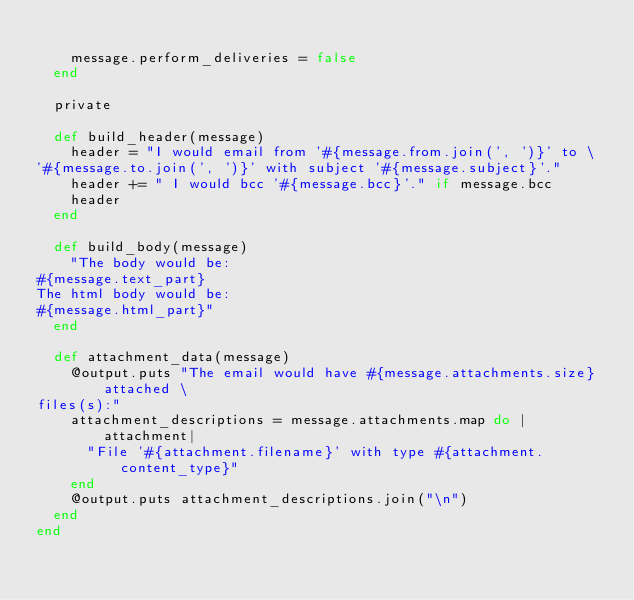<code> <loc_0><loc_0><loc_500><loc_500><_Ruby_>
    message.perform_deliveries = false
  end

  private

  def build_header(message)
    header = "I would email from '#{message.from.join(', ')}' to \
'#{message.to.join(', ')}' with subject '#{message.subject}'."
    header += " I would bcc '#{message.bcc}'." if message.bcc
    header
  end

  def build_body(message)
    "The body would be:
#{message.text_part}
The html body would be:
#{message.html_part}"
  end

  def attachment_data(message)
    @output.puts "The email would have #{message.attachments.size} attached \
files(s):"
    attachment_descriptions = message.attachments.map do |attachment|
      "File '#{attachment.filename}' with type #{attachment.content_type}"
    end
    @output.puts attachment_descriptions.join("\n")
  end
end
</code> 